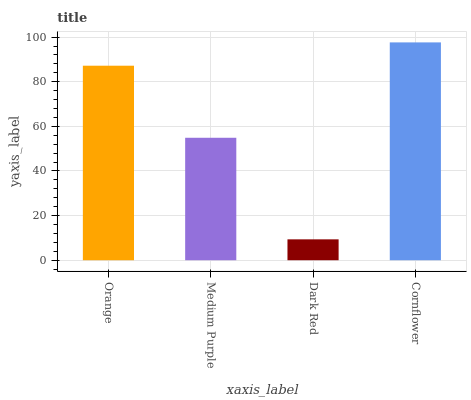Is Dark Red the minimum?
Answer yes or no. Yes. Is Cornflower the maximum?
Answer yes or no. Yes. Is Medium Purple the minimum?
Answer yes or no. No. Is Medium Purple the maximum?
Answer yes or no. No. Is Orange greater than Medium Purple?
Answer yes or no. Yes. Is Medium Purple less than Orange?
Answer yes or no. Yes. Is Medium Purple greater than Orange?
Answer yes or no. No. Is Orange less than Medium Purple?
Answer yes or no. No. Is Orange the high median?
Answer yes or no. Yes. Is Medium Purple the low median?
Answer yes or no. Yes. Is Dark Red the high median?
Answer yes or no. No. Is Orange the low median?
Answer yes or no. No. 